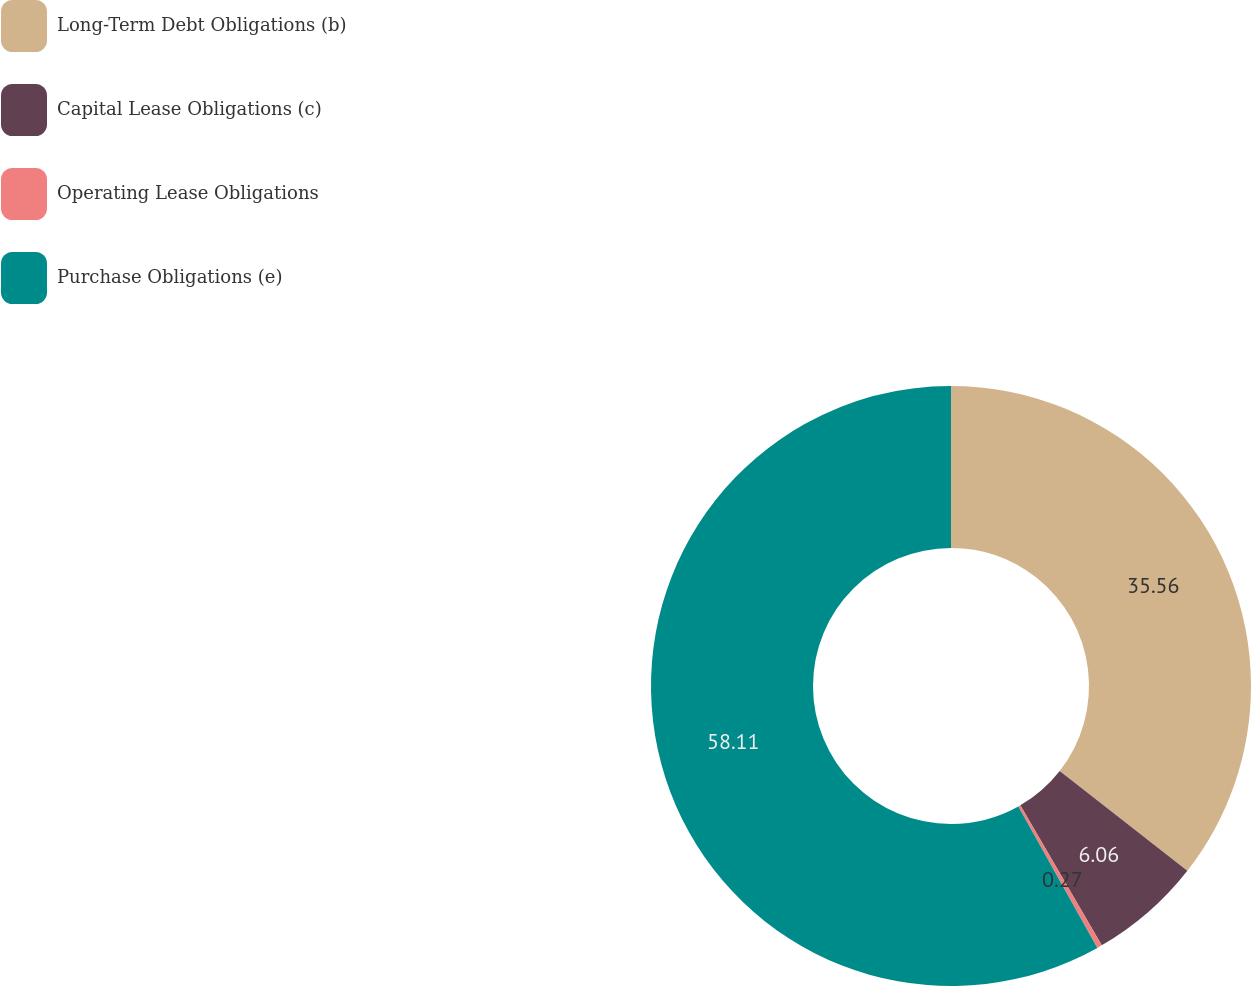<chart> <loc_0><loc_0><loc_500><loc_500><pie_chart><fcel>Long-Term Debt Obligations (b)<fcel>Capital Lease Obligations (c)<fcel>Operating Lease Obligations<fcel>Purchase Obligations (e)<nl><fcel>35.56%<fcel>6.06%<fcel>0.27%<fcel>58.11%<nl></chart> 